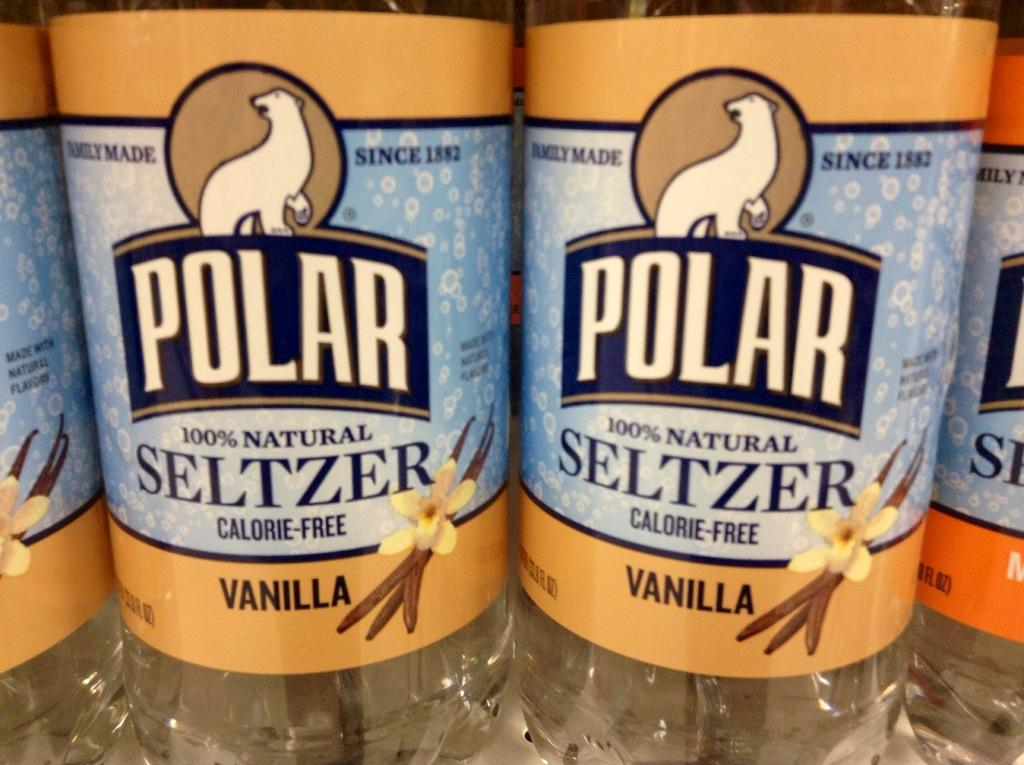Provide a one-sentence caption for the provided image. Close up of two bottles of Polar vanilla flavoured seltzer. 